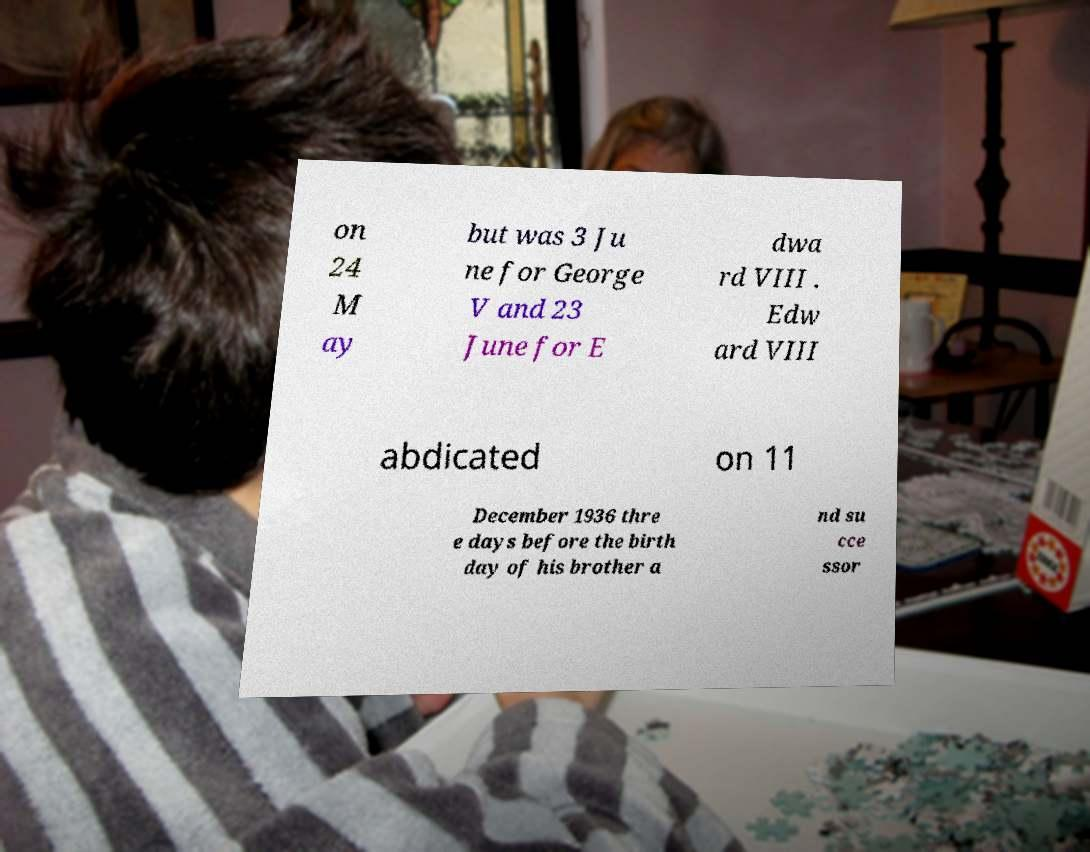For documentation purposes, I need the text within this image transcribed. Could you provide that? on 24 M ay but was 3 Ju ne for George V and 23 June for E dwa rd VIII . Edw ard VIII abdicated on 11 December 1936 thre e days before the birth day of his brother a nd su cce ssor 